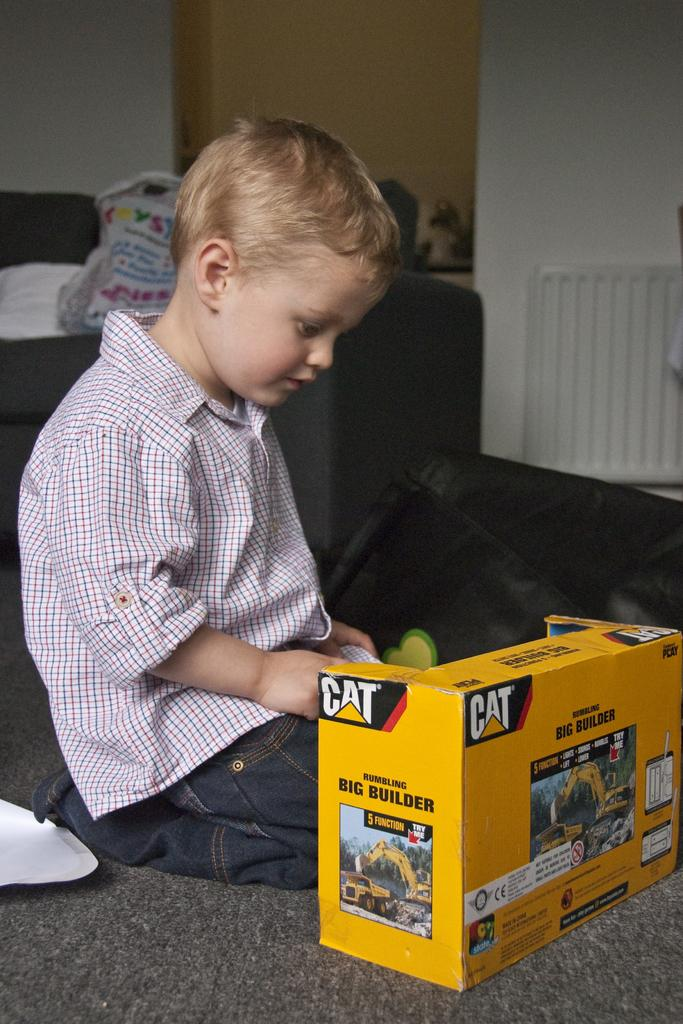<image>
Provide a brief description of the given image. a young boy playing with a CAT big builder toy 